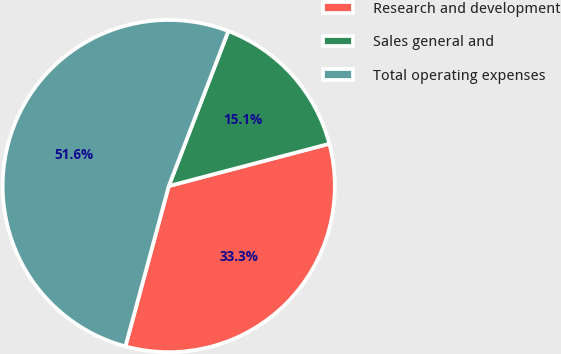Convert chart. <chart><loc_0><loc_0><loc_500><loc_500><pie_chart><fcel>Research and development<fcel>Sales general and<fcel>Total operating expenses<nl><fcel>33.3%<fcel>15.06%<fcel>51.64%<nl></chart> 